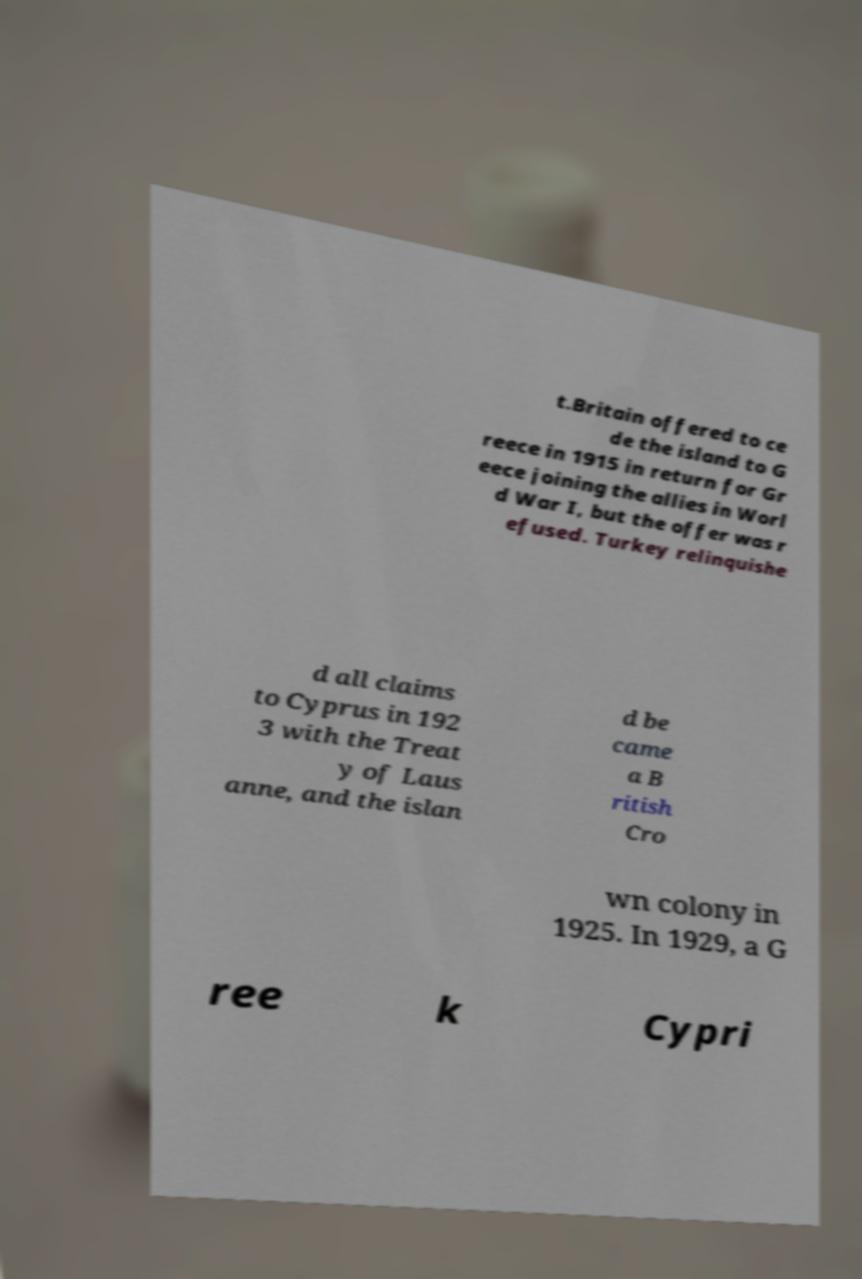Please identify and transcribe the text found in this image. t.Britain offered to ce de the island to G reece in 1915 in return for Gr eece joining the allies in Worl d War I, but the offer was r efused. Turkey relinquishe d all claims to Cyprus in 192 3 with the Treat y of Laus anne, and the islan d be came a B ritish Cro wn colony in 1925. In 1929, a G ree k Cypri 